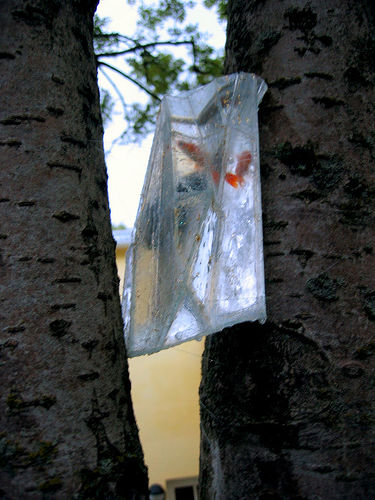<image>
Can you confirm if the fish is above the tree? No. The fish is not positioned above the tree. The vertical arrangement shows a different relationship. 